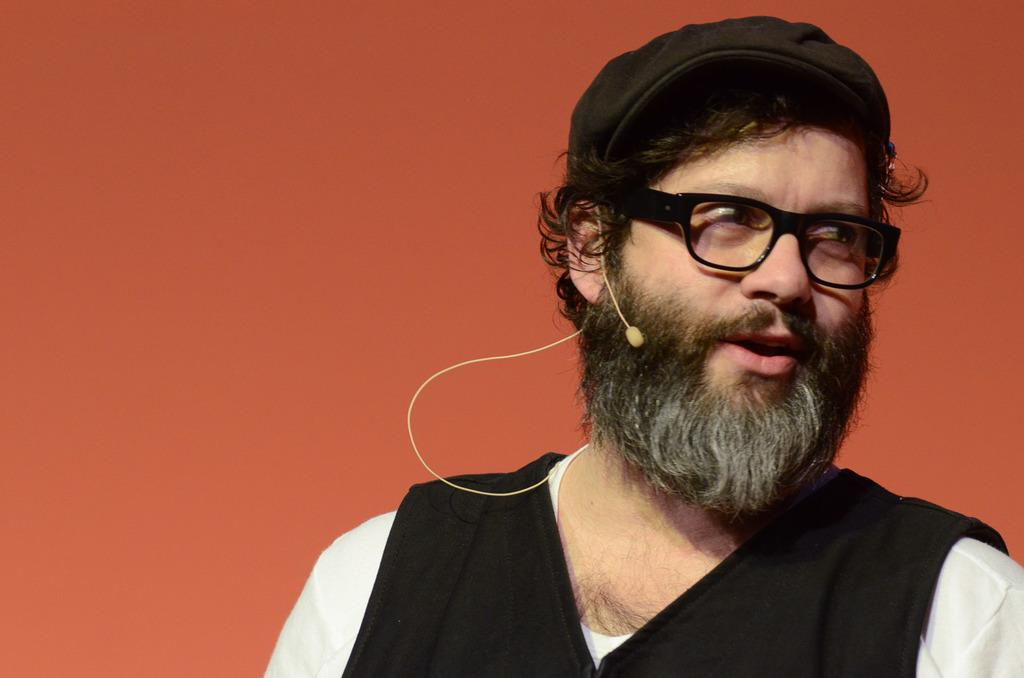Who is present in the image? There is a man in the image. Where is the man located in the image? The man is towards the right side of the image. What is the man wearing? The man is wearing a black jacket and a white t-shirt. What accessory is the man wearing? The man is wearing spectacles. What is the man holding in the image? The man is holding a microphone. What is the color of the background in the image? The background of the image is in orange. What type of meat is being cooked in the image? There is no meat present in the image; it features a man holding a microphone. What punishment is being given to the egg in the image? There is no egg present in the image, and therefore no punishment can be observed. 